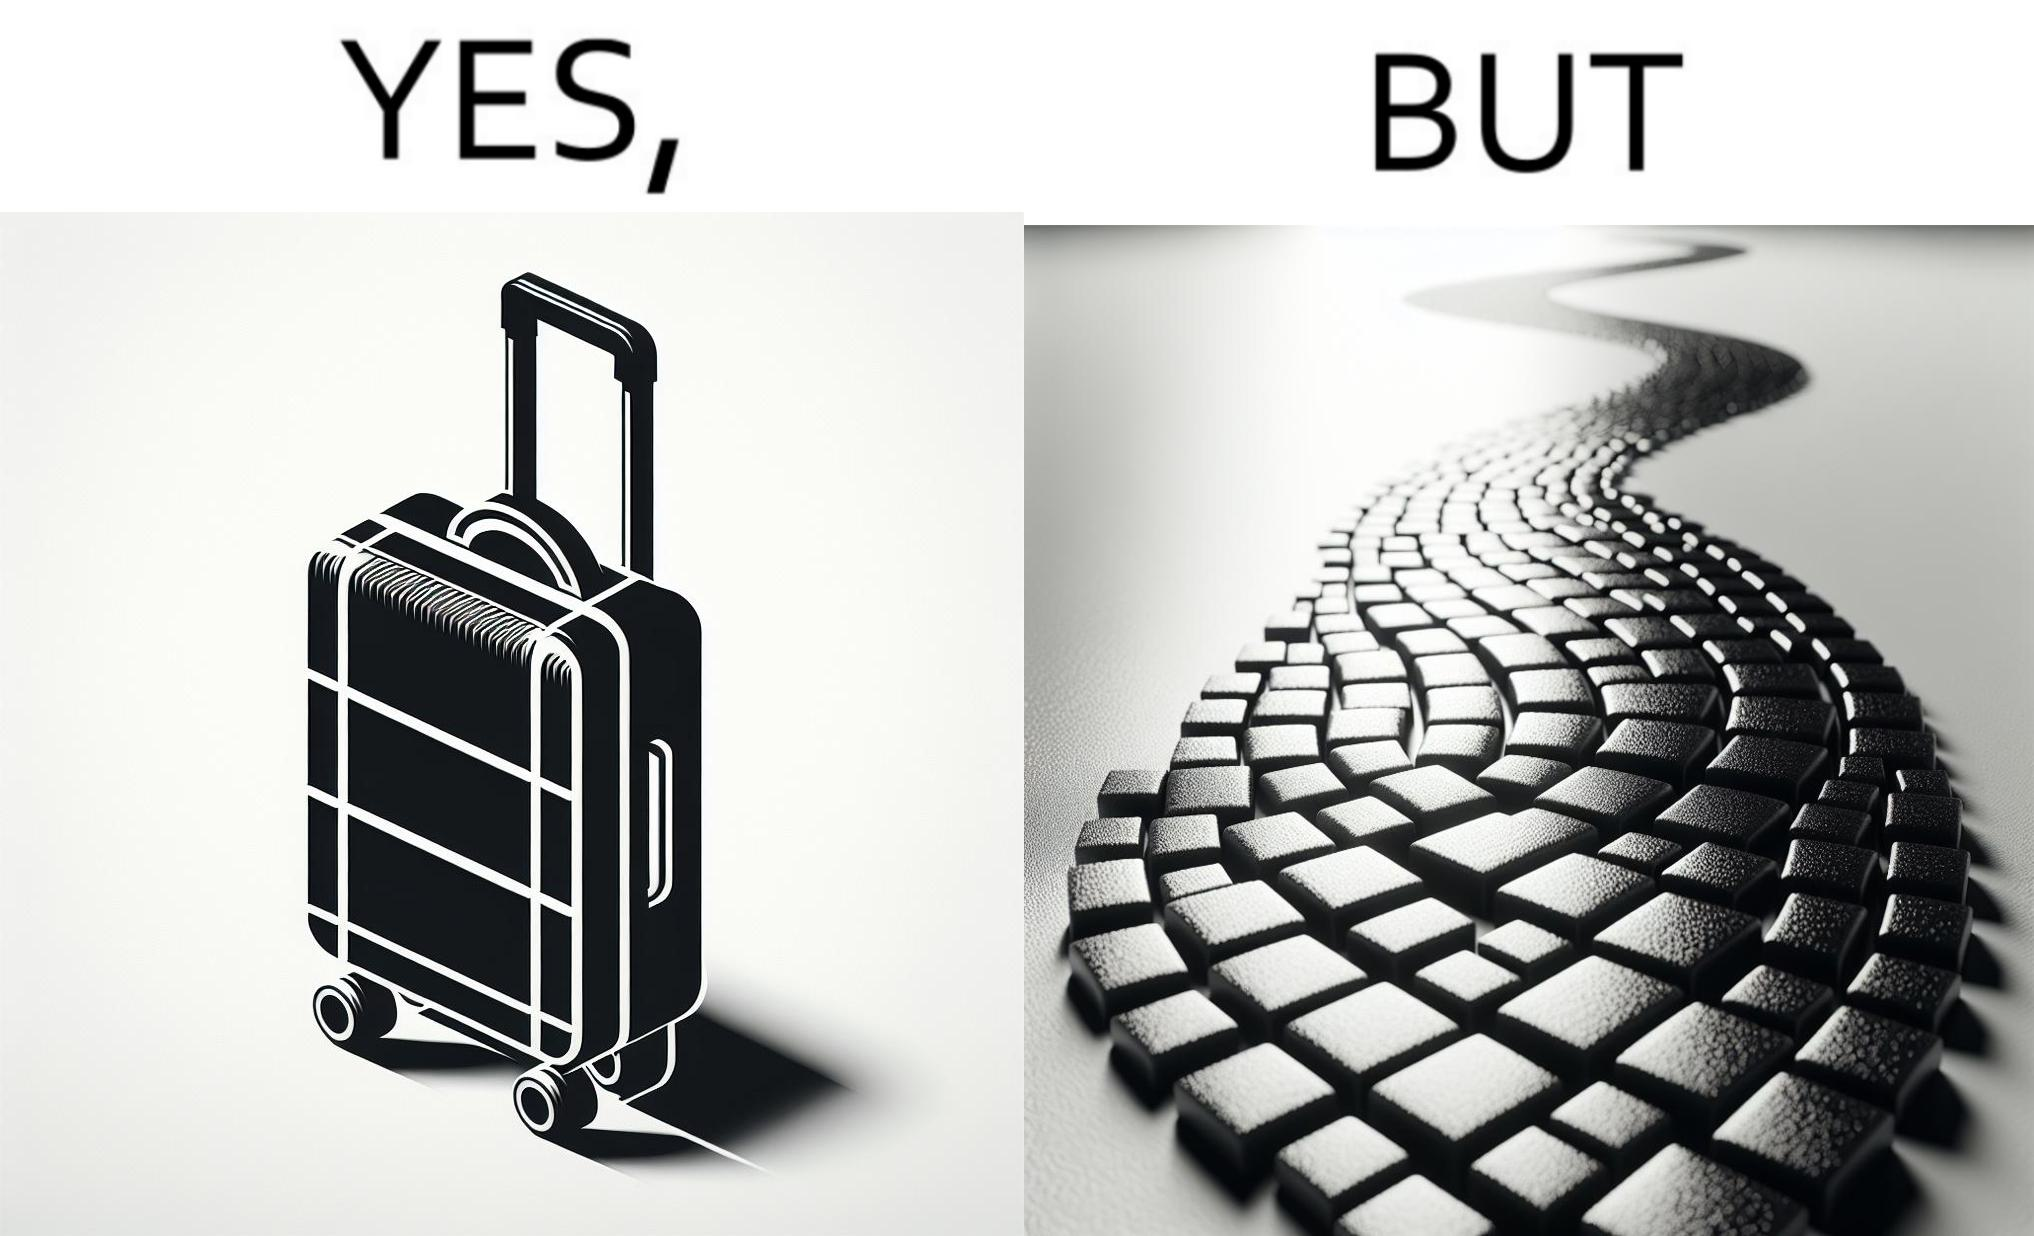Does this image contain satire or humor? Yes, this image is satirical. 